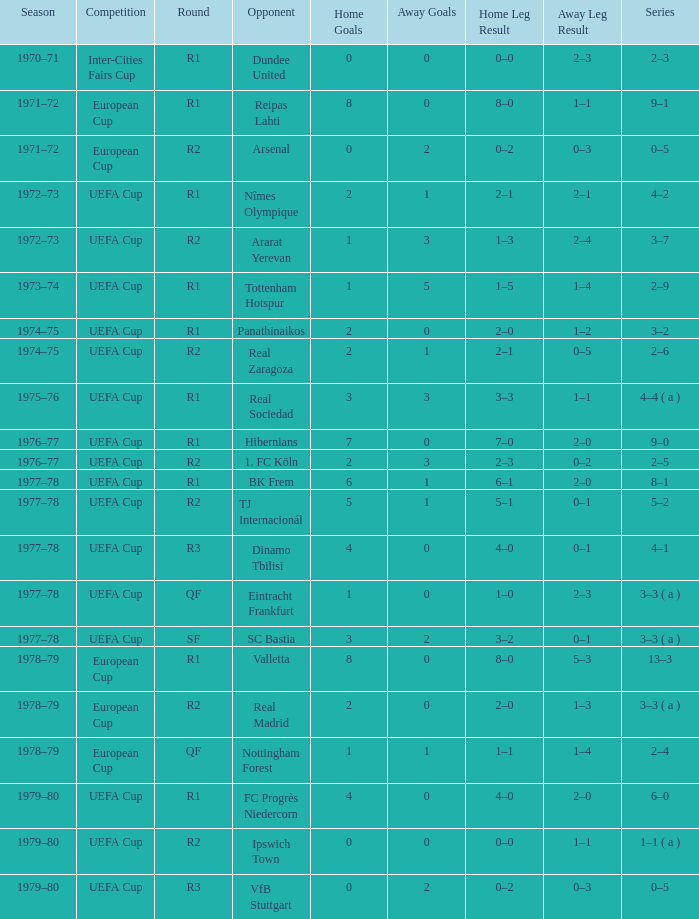Which Home has a Competition of european cup, and a Round of qf? 1–1. 